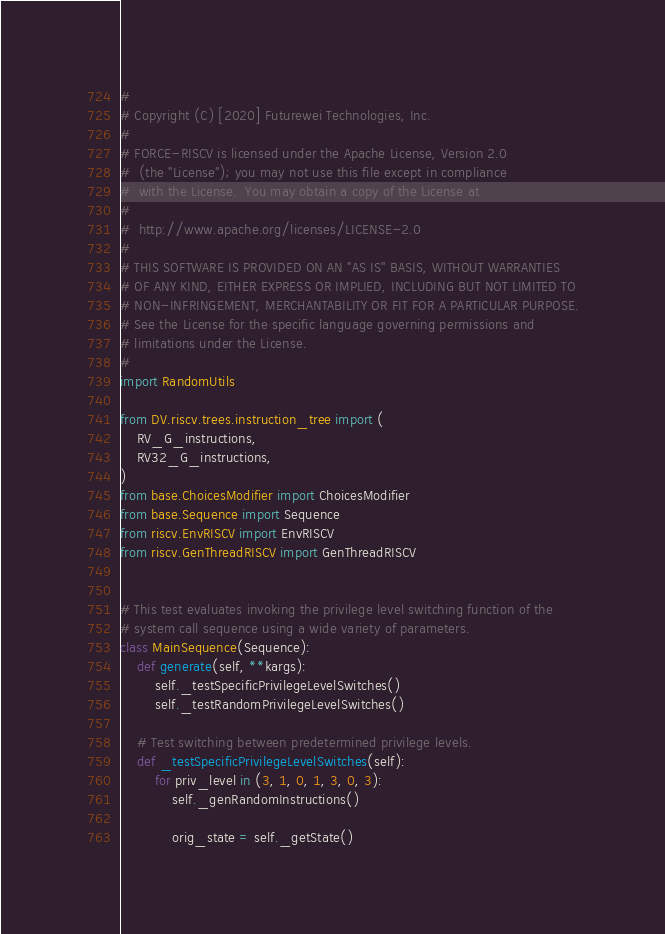Convert code to text. <code><loc_0><loc_0><loc_500><loc_500><_Python_>#
# Copyright (C) [2020] Futurewei Technologies, Inc.
#
# FORCE-RISCV is licensed under the Apache License, Version 2.0
#  (the "License"); you may not use this file except in compliance
#  with the License.  You may obtain a copy of the License at
#
#  http://www.apache.org/licenses/LICENSE-2.0
#
# THIS SOFTWARE IS PROVIDED ON AN "AS IS" BASIS, WITHOUT WARRANTIES
# OF ANY KIND, EITHER EXPRESS OR IMPLIED, INCLUDING BUT NOT LIMITED TO
# NON-INFRINGEMENT, MERCHANTABILITY OR FIT FOR A PARTICULAR PURPOSE.
# See the License for the specific language governing permissions and
# limitations under the License.
#
import RandomUtils

from DV.riscv.trees.instruction_tree import (
    RV_G_instructions,
    RV32_G_instructions,
)
from base.ChoicesModifier import ChoicesModifier
from base.Sequence import Sequence
from riscv.EnvRISCV import EnvRISCV
from riscv.GenThreadRISCV import GenThreadRISCV


# This test evaluates invoking the privilege level switching function of the
# system call sequence using a wide variety of parameters.
class MainSequence(Sequence):
    def generate(self, **kargs):
        self._testSpecificPrivilegeLevelSwitches()
        self._testRandomPrivilegeLevelSwitches()

    # Test switching between predetermined privilege levels.
    def _testSpecificPrivilegeLevelSwitches(self):
        for priv_level in (3, 1, 0, 1, 3, 0, 3):
            self._genRandomInstructions()

            orig_state = self._getState()</code> 